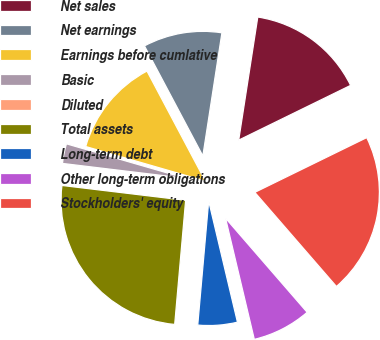Convert chart. <chart><loc_0><loc_0><loc_500><loc_500><pie_chart><fcel>Net sales<fcel>Net earnings<fcel>Earnings before cumlative<fcel>Basic<fcel>Diluted<fcel>Total assets<fcel>Long-term debt<fcel>Other long-term obligations<fcel>Stockholders' equity<nl><fcel>15.31%<fcel>10.21%<fcel>12.76%<fcel>2.56%<fcel>0.01%<fcel>25.5%<fcel>5.11%<fcel>7.66%<fcel>20.87%<nl></chart> 